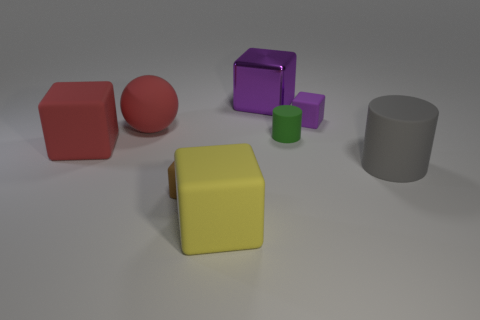Subtract all small brown matte cubes. How many cubes are left? 4 Subtract all brown cubes. How many cubes are left? 4 Subtract all gray blocks. Subtract all brown cylinders. How many blocks are left? 5 Add 1 big purple metal blocks. How many objects exist? 9 Subtract all cylinders. How many objects are left? 6 Subtract 0 purple cylinders. How many objects are left? 8 Subtract all big yellow shiny balls. Subtract all large yellow things. How many objects are left? 7 Add 5 shiny objects. How many shiny objects are left? 6 Add 8 small brown blocks. How many small brown blocks exist? 9 